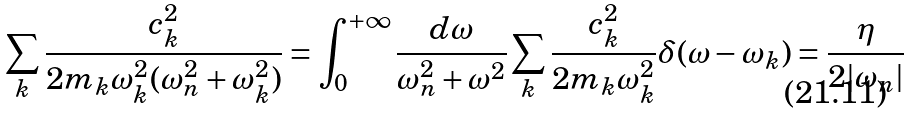<formula> <loc_0><loc_0><loc_500><loc_500>\sum _ { k } \frac { c _ { k } ^ { 2 } } { 2 m _ { k } { \omega } _ { k } ^ { 2 } ( { \omega } _ { n } ^ { 2 } + { \omega } _ { k } ^ { 2 } ) } = \int _ { 0 } ^ { + \infty } \frac { d \omega } { { \omega } _ { n } ^ { 2 } + { \omega } ^ { 2 } } \sum _ { k } \frac { c _ { k } ^ { 2 } } { 2 m _ { k } { \omega } _ { k } ^ { 2 } } { \delta } ( { \omega } - { \omega } _ { k } ) = \frac { \eta } { 2 | { \omega } _ { n } | }</formula> 